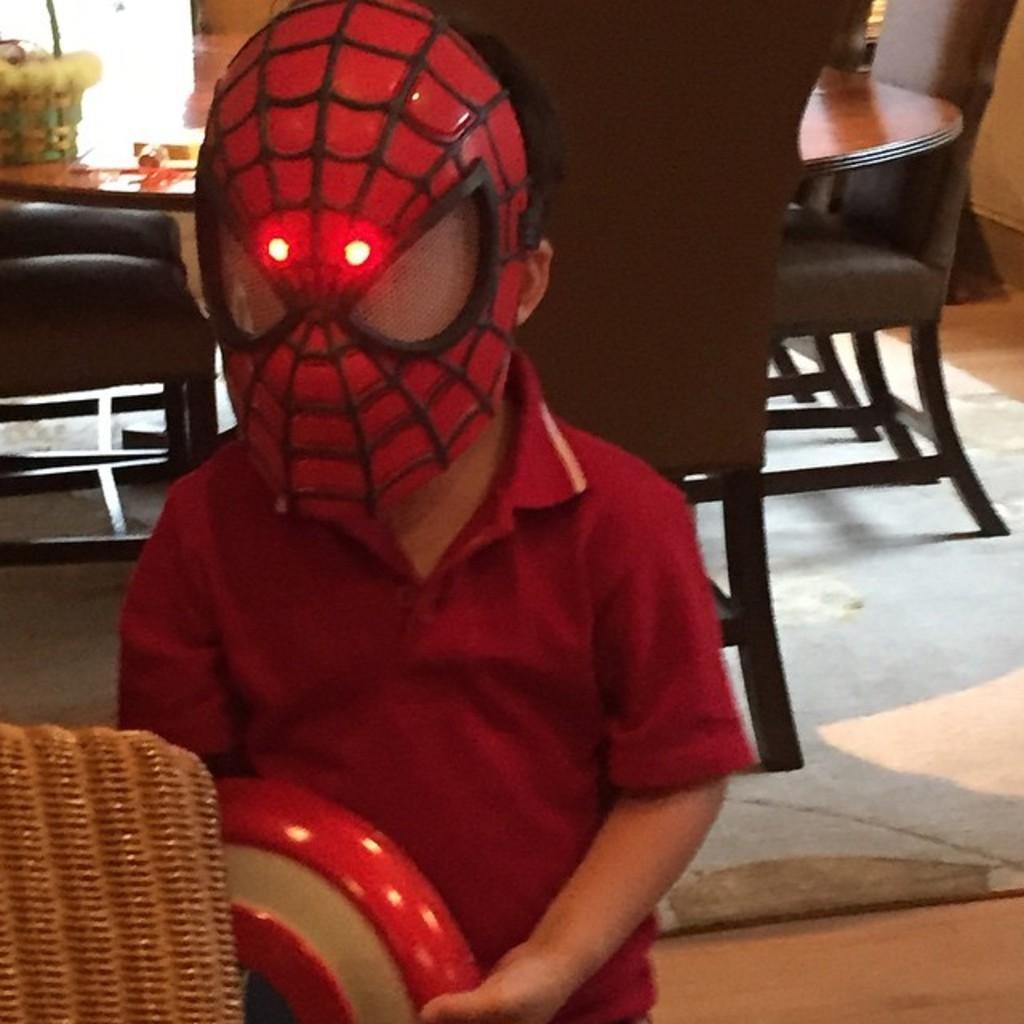Please provide a concise description of this image. In this picture I can see a boy who is standing in front and I see that he is wearing a spider man mask on his face. In the background I see the table on which there is a thing and I see the chairs around it and I see the floor. 